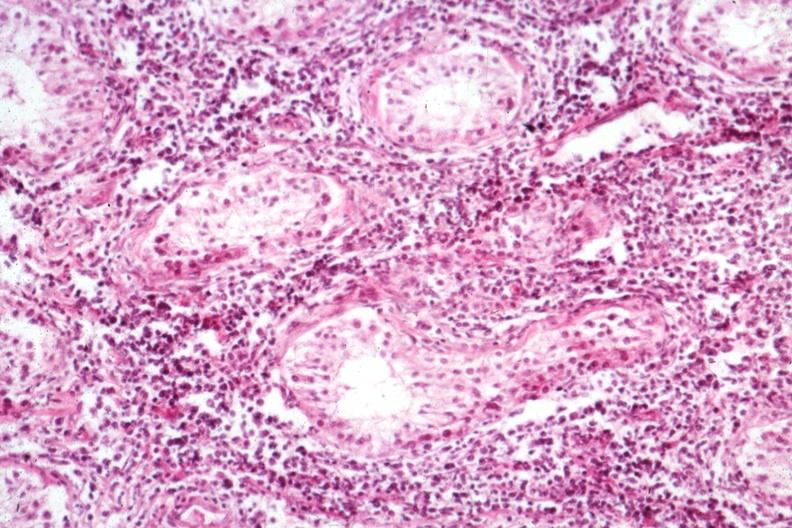what is present?
Answer the question using a single word or phrase. Testicle 